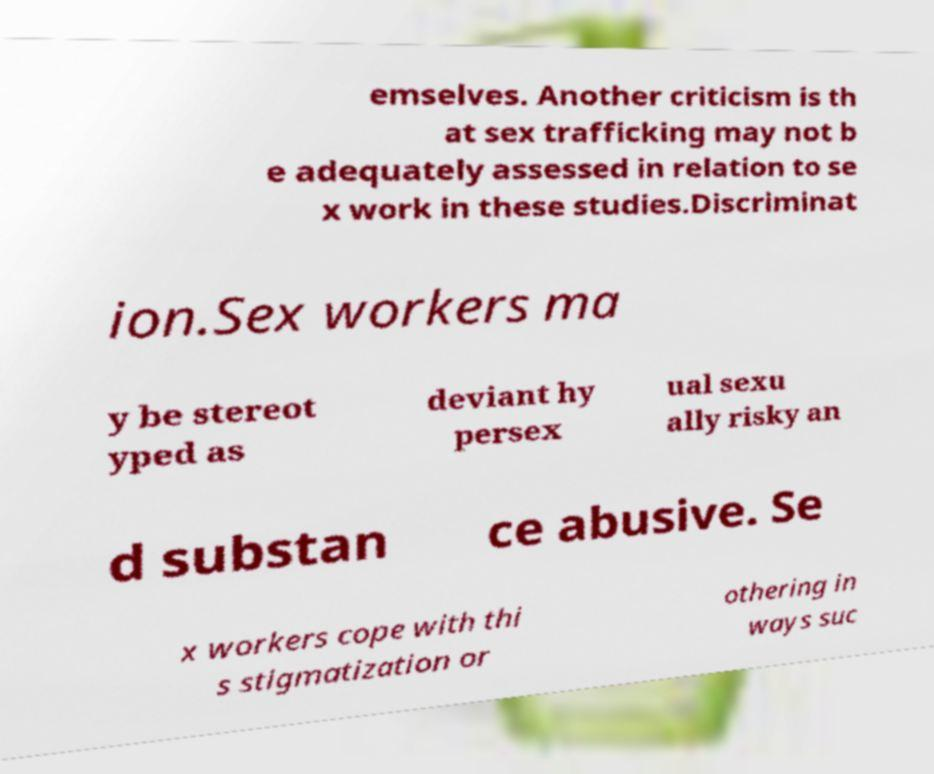Can you accurately transcribe the text from the provided image for me? emselves. Another criticism is th at sex trafficking may not b e adequately assessed in relation to se x work in these studies.Discriminat ion.Sex workers ma y be stereot yped as deviant hy persex ual sexu ally risky an d substan ce abusive. Se x workers cope with thi s stigmatization or othering in ways suc 